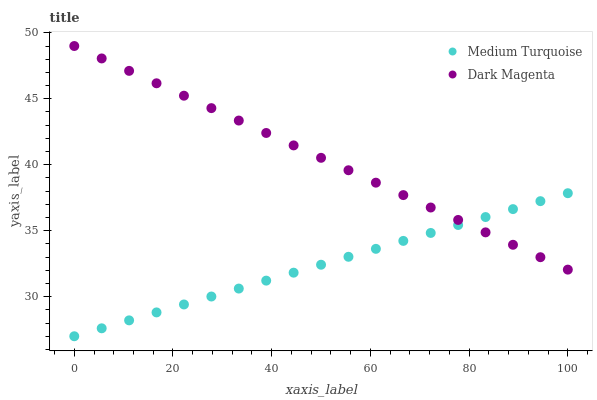Does Medium Turquoise have the minimum area under the curve?
Answer yes or no. Yes. Does Dark Magenta have the maximum area under the curve?
Answer yes or no. Yes. Does Medium Turquoise have the maximum area under the curve?
Answer yes or no. No. Is Medium Turquoise the smoothest?
Answer yes or no. Yes. Is Dark Magenta the roughest?
Answer yes or no. Yes. Is Medium Turquoise the roughest?
Answer yes or no. No. Does Medium Turquoise have the lowest value?
Answer yes or no. Yes. Does Dark Magenta have the highest value?
Answer yes or no. Yes. Does Medium Turquoise have the highest value?
Answer yes or no. No. Does Dark Magenta intersect Medium Turquoise?
Answer yes or no. Yes. Is Dark Magenta less than Medium Turquoise?
Answer yes or no. No. Is Dark Magenta greater than Medium Turquoise?
Answer yes or no. No. 